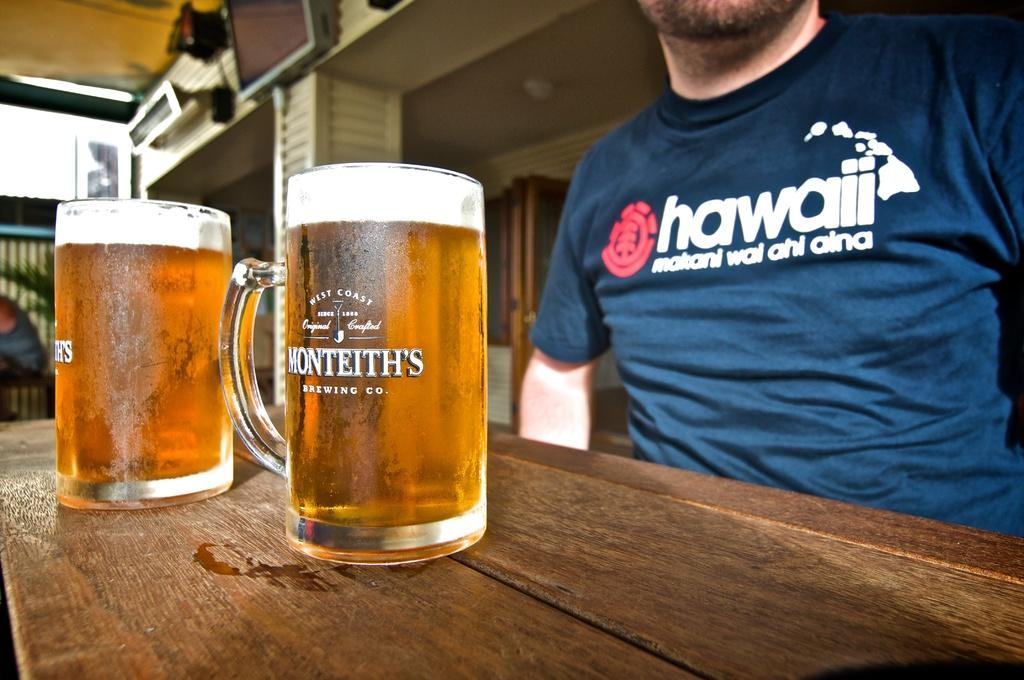Provide a one-sentence caption for the provided image. A man wearing a Hawaii shirt sits in front of two mugs of beer. 